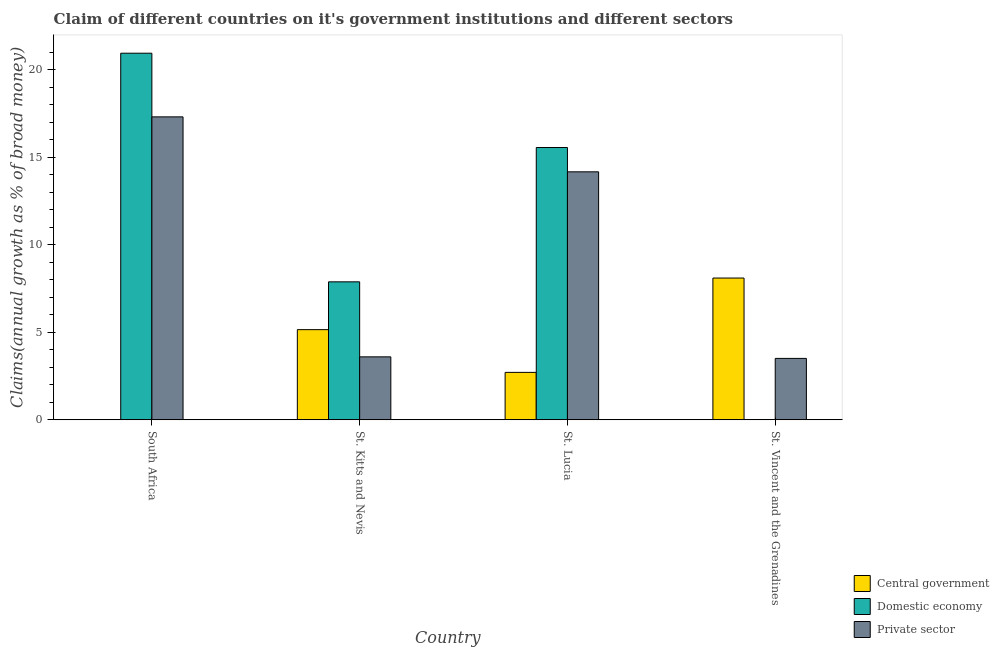How many different coloured bars are there?
Your answer should be compact. 3. How many groups of bars are there?
Keep it short and to the point. 4. Are the number of bars per tick equal to the number of legend labels?
Keep it short and to the point. No. How many bars are there on the 3rd tick from the left?
Give a very brief answer. 3. What is the label of the 3rd group of bars from the left?
Provide a short and direct response. St. Lucia. What is the percentage of claim on the domestic economy in St. Kitts and Nevis?
Your response must be concise. 7.88. Across all countries, what is the maximum percentage of claim on the central government?
Provide a short and direct response. 8.1. In which country was the percentage of claim on the domestic economy maximum?
Provide a short and direct response. South Africa. What is the total percentage of claim on the domestic economy in the graph?
Your response must be concise. 44.36. What is the difference between the percentage of claim on the private sector in St. Kitts and Nevis and that in St. Lucia?
Provide a succinct answer. -10.57. What is the difference between the percentage of claim on the domestic economy in St. Vincent and the Grenadines and the percentage of claim on the private sector in St. Kitts and Nevis?
Offer a terse response. -3.6. What is the average percentage of claim on the domestic economy per country?
Your answer should be very brief. 11.09. What is the difference between the percentage of claim on the domestic economy and percentage of claim on the central government in St. Lucia?
Your answer should be very brief. 12.84. What is the ratio of the percentage of claim on the private sector in South Africa to that in St. Lucia?
Ensure brevity in your answer.  1.22. Is the percentage of claim on the private sector in South Africa less than that in St. Kitts and Nevis?
Your answer should be very brief. No. What is the difference between the highest and the second highest percentage of claim on the domestic economy?
Provide a succinct answer. 5.39. What is the difference between the highest and the lowest percentage of claim on the central government?
Give a very brief answer. 8.1. In how many countries, is the percentage of claim on the central government greater than the average percentage of claim on the central government taken over all countries?
Provide a succinct answer. 2. Are all the bars in the graph horizontal?
Provide a short and direct response. No. How many countries are there in the graph?
Provide a short and direct response. 4. What is the difference between two consecutive major ticks on the Y-axis?
Make the answer very short. 5. Does the graph contain any zero values?
Ensure brevity in your answer.  Yes. Does the graph contain grids?
Your answer should be very brief. No. Where does the legend appear in the graph?
Keep it short and to the point. Bottom right. How many legend labels are there?
Ensure brevity in your answer.  3. What is the title of the graph?
Provide a succinct answer. Claim of different countries on it's government institutions and different sectors. Does "Argument" appear as one of the legend labels in the graph?
Your answer should be very brief. No. What is the label or title of the Y-axis?
Your answer should be very brief. Claims(annual growth as % of broad money). What is the Claims(annual growth as % of broad money) in Central government in South Africa?
Provide a short and direct response. 0. What is the Claims(annual growth as % of broad money) in Domestic economy in South Africa?
Offer a terse response. 20.93. What is the Claims(annual growth as % of broad money) of Private sector in South Africa?
Offer a terse response. 17.3. What is the Claims(annual growth as % of broad money) of Central government in St. Kitts and Nevis?
Give a very brief answer. 5.15. What is the Claims(annual growth as % of broad money) in Domestic economy in St. Kitts and Nevis?
Ensure brevity in your answer.  7.88. What is the Claims(annual growth as % of broad money) in Private sector in St. Kitts and Nevis?
Provide a short and direct response. 3.6. What is the Claims(annual growth as % of broad money) of Central government in St. Lucia?
Keep it short and to the point. 2.71. What is the Claims(annual growth as % of broad money) in Domestic economy in St. Lucia?
Give a very brief answer. 15.55. What is the Claims(annual growth as % of broad money) in Private sector in St. Lucia?
Offer a very short reply. 14.16. What is the Claims(annual growth as % of broad money) in Central government in St. Vincent and the Grenadines?
Your answer should be compact. 8.1. What is the Claims(annual growth as % of broad money) of Private sector in St. Vincent and the Grenadines?
Provide a short and direct response. 3.51. Across all countries, what is the maximum Claims(annual growth as % of broad money) in Central government?
Provide a short and direct response. 8.1. Across all countries, what is the maximum Claims(annual growth as % of broad money) in Domestic economy?
Give a very brief answer. 20.93. Across all countries, what is the maximum Claims(annual growth as % of broad money) in Private sector?
Make the answer very short. 17.3. Across all countries, what is the minimum Claims(annual growth as % of broad money) of Private sector?
Offer a very short reply. 3.51. What is the total Claims(annual growth as % of broad money) of Central government in the graph?
Offer a very short reply. 15.95. What is the total Claims(annual growth as % of broad money) of Domestic economy in the graph?
Your answer should be compact. 44.36. What is the total Claims(annual growth as % of broad money) in Private sector in the graph?
Give a very brief answer. 38.56. What is the difference between the Claims(annual growth as % of broad money) of Domestic economy in South Africa and that in St. Kitts and Nevis?
Your response must be concise. 13.06. What is the difference between the Claims(annual growth as % of broad money) of Private sector in South Africa and that in St. Kitts and Nevis?
Make the answer very short. 13.7. What is the difference between the Claims(annual growth as % of broad money) of Domestic economy in South Africa and that in St. Lucia?
Make the answer very short. 5.39. What is the difference between the Claims(annual growth as % of broad money) of Private sector in South Africa and that in St. Lucia?
Offer a very short reply. 3.14. What is the difference between the Claims(annual growth as % of broad money) of Private sector in South Africa and that in St. Vincent and the Grenadines?
Provide a succinct answer. 13.79. What is the difference between the Claims(annual growth as % of broad money) of Central government in St. Kitts and Nevis and that in St. Lucia?
Offer a very short reply. 2.44. What is the difference between the Claims(annual growth as % of broad money) of Domestic economy in St. Kitts and Nevis and that in St. Lucia?
Offer a terse response. -7.67. What is the difference between the Claims(annual growth as % of broad money) in Private sector in St. Kitts and Nevis and that in St. Lucia?
Offer a very short reply. -10.57. What is the difference between the Claims(annual growth as % of broad money) of Central government in St. Kitts and Nevis and that in St. Vincent and the Grenadines?
Offer a terse response. -2.95. What is the difference between the Claims(annual growth as % of broad money) in Private sector in St. Kitts and Nevis and that in St. Vincent and the Grenadines?
Offer a very short reply. 0.09. What is the difference between the Claims(annual growth as % of broad money) of Central government in St. Lucia and that in St. Vincent and the Grenadines?
Your answer should be compact. -5.39. What is the difference between the Claims(annual growth as % of broad money) in Private sector in St. Lucia and that in St. Vincent and the Grenadines?
Your answer should be compact. 10.65. What is the difference between the Claims(annual growth as % of broad money) of Domestic economy in South Africa and the Claims(annual growth as % of broad money) of Private sector in St. Kitts and Nevis?
Your answer should be very brief. 17.34. What is the difference between the Claims(annual growth as % of broad money) in Domestic economy in South Africa and the Claims(annual growth as % of broad money) in Private sector in St. Lucia?
Give a very brief answer. 6.77. What is the difference between the Claims(annual growth as % of broad money) in Domestic economy in South Africa and the Claims(annual growth as % of broad money) in Private sector in St. Vincent and the Grenadines?
Ensure brevity in your answer.  17.43. What is the difference between the Claims(annual growth as % of broad money) in Central government in St. Kitts and Nevis and the Claims(annual growth as % of broad money) in Domestic economy in St. Lucia?
Offer a very short reply. -10.4. What is the difference between the Claims(annual growth as % of broad money) in Central government in St. Kitts and Nevis and the Claims(annual growth as % of broad money) in Private sector in St. Lucia?
Give a very brief answer. -9.01. What is the difference between the Claims(annual growth as % of broad money) in Domestic economy in St. Kitts and Nevis and the Claims(annual growth as % of broad money) in Private sector in St. Lucia?
Offer a terse response. -6.28. What is the difference between the Claims(annual growth as % of broad money) of Central government in St. Kitts and Nevis and the Claims(annual growth as % of broad money) of Private sector in St. Vincent and the Grenadines?
Make the answer very short. 1.64. What is the difference between the Claims(annual growth as % of broad money) of Domestic economy in St. Kitts and Nevis and the Claims(annual growth as % of broad money) of Private sector in St. Vincent and the Grenadines?
Make the answer very short. 4.37. What is the difference between the Claims(annual growth as % of broad money) of Central government in St. Lucia and the Claims(annual growth as % of broad money) of Private sector in St. Vincent and the Grenadines?
Keep it short and to the point. -0.8. What is the difference between the Claims(annual growth as % of broad money) of Domestic economy in St. Lucia and the Claims(annual growth as % of broad money) of Private sector in St. Vincent and the Grenadines?
Your answer should be very brief. 12.04. What is the average Claims(annual growth as % of broad money) of Central government per country?
Make the answer very short. 3.99. What is the average Claims(annual growth as % of broad money) in Domestic economy per country?
Provide a short and direct response. 11.09. What is the average Claims(annual growth as % of broad money) in Private sector per country?
Ensure brevity in your answer.  9.64. What is the difference between the Claims(annual growth as % of broad money) of Domestic economy and Claims(annual growth as % of broad money) of Private sector in South Africa?
Make the answer very short. 3.63. What is the difference between the Claims(annual growth as % of broad money) of Central government and Claims(annual growth as % of broad money) of Domestic economy in St. Kitts and Nevis?
Offer a very short reply. -2.73. What is the difference between the Claims(annual growth as % of broad money) in Central government and Claims(annual growth as % of broad money) in Private sector in St. Kitts and Nevis?
Your answer should be compact. 1.55. What is the difference between the Claims(annual growth as % of broad money) of Domestic economy and Claims(annual growth as % of broad money) of Private sector in St. Kitts and Nevis?
Ensure brevity in your answer.  4.28. What is the difference between the Claims(annual growth as % of broad money) in Central government and Claims(annual growth as % of broad money) in Domestic economy in St. Lucia?
Give a very brief answer. -12.84. What is the difference between the Claims(annual growth as % of broad money) of Central government and Claims(annual growth as % of broad money) of Private sector in St. Lucia?
Keep it short and to the point. -11.45. What is the difference between the Claims(annual growth as % of broad money) of Domestic economy and Claims(annual growth as % of broad money) of Private sector in St. Lucia?
Your answer should be compact. 1.39. What is the difference between the Claims(annual growth as % of broad money) of Central government and Claims(annual growth as % of broad money) of Private sector in St. Vincent and the Grenadines?
Your response must be concise. 4.59. What is the ratio of the Claims(annual growth as % of broad money) in Domestic economy in South Africa to that in St. Kitts and Nevis?
Your response must be concise. 2.66. What is the ratio of the Claims(annual growth as % of broad money) of Private sector in South Africa to that in St. Kitts and Nevis?
Give a very brief answer. 4.81. What is the ratio of the Claims(annual growth as % of broad money) of Domestic economy in South Africa to that in St. Lucia?
Your response must be concise. 1.35. What is the ratio of the Claims(annual growth as % of broad money) in Private sector in South Africa to that in St. Lucia?
Provide a short and direct response. 1.22. What is the ratio of the Claims(annual growth as % of broad money) in Private sector in South Africa to that in St. Vincent and the Grenadines?
Provide a short and direct response. 4.93. What is the ratio of the Claims(annual growth as % of broad money) of Central government in St. Kitts and Nevis to that in St. Lucia?
Keep it short and to the point. 1.9. What is the ratio of the Claims(annual growth as % of broad money) in Domestic economy in St. Kitts and Nevis to that in St. Lucia?
Your answer should be very brief. 0.51. What is the ratio of the Claims(annual growth as % of broad money) of Private sector in St. Kitts and Nevis to that in St. Lucia?
Provide a succinct answer. 0.25. What is the ratio of the Claims(annual growth as % of broad money) of Central government in St. Kitts and Nevis to that in St. Vincent and the Grenadines?
Keep it short and to the point. 0.64. What is the ratio of the Claims(annual growth as % of broad money) in Private sector in St. Kitts and Nevis to that in St. Vincent and the Grenadines?
Provide a short and direct response. 1.03. What is the ratio of the Claims(annual growth as % of broad money) in Central government in St. Lucia to that in St. Vincent and the Grenadines?
Keep it short and to the point. 0.33. What is the ratio of the Claims(annual growth as % of broad money) in Private sector in St. Lucia to that in St. Vincent and the Grenadines?
Provide a succinct answer. 4.04. What is the difference between the highest and the second highest Claims(annual growth as % of broad money) in Central government?
Offer a terse response. 2.95. What is the difference between the highest and the second highest Claims(annual growth as % of broad money) in Domestic economy?
Keep it short and to the point. 5.39. What is the difference between the highest and the second highest Claims(annual growth as % of broad money) of Private sector?
Provide a short and direct response. 3.14. What is the difference between the highest and the lowest Claims(annual growth as % of broad money) of Central government?
Your answer should be very brief. 8.1. What is the difference between the highest and the lowest Claims(annual growth as % of broad money) in Domestic economy?
Give a very brief answer. 20.93. What is the difference between the highest and the lowest Claims(annual growth as % of broad money) in Private sector?
Ensure brevity in your answer.  13.79. 